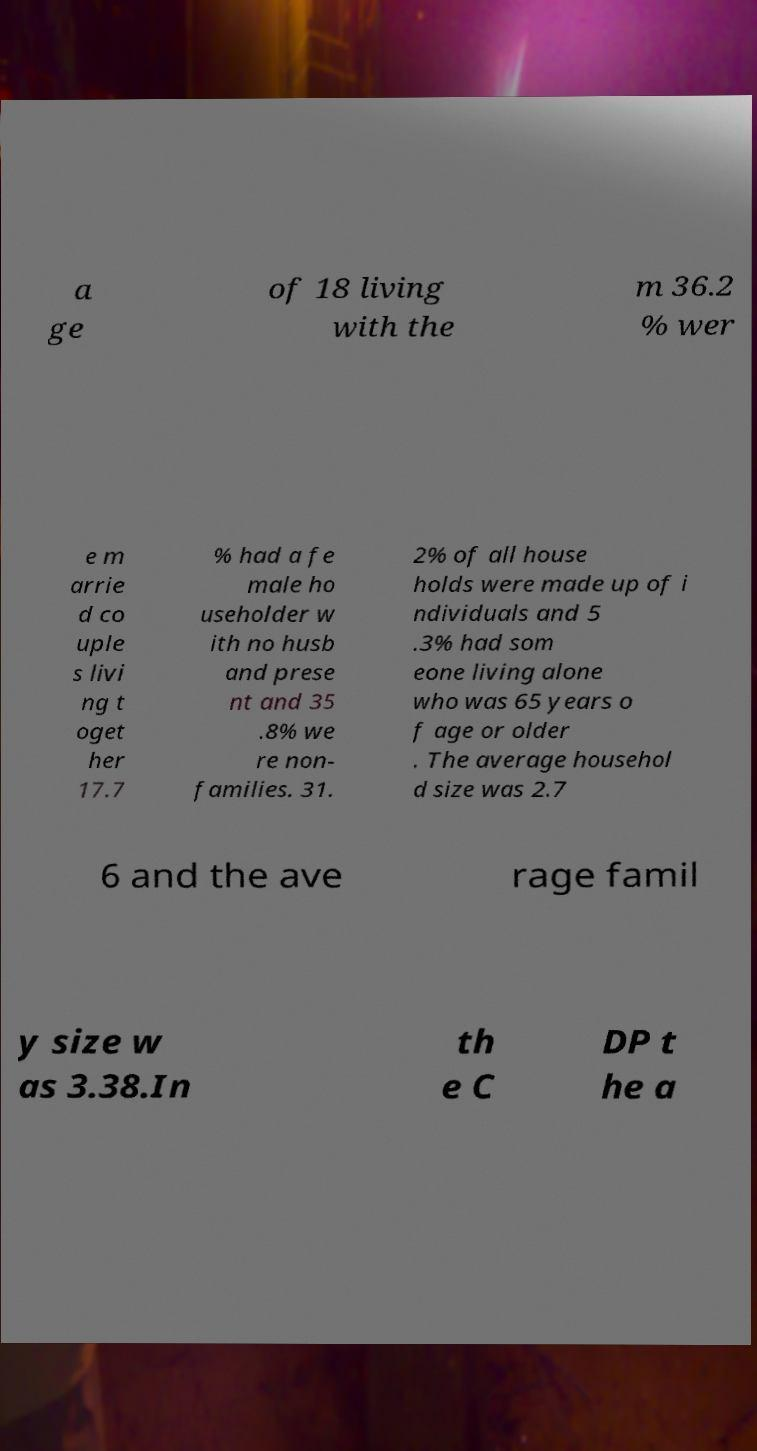Could you extract and type out the text from this image? a ge of 18 living with the m 36.2 % wer e m arrie d co uple s livi ng t oget her 17.7 % had a fe male ho useholder w ith no husb and prese nt and 35 .8% we re non- families. 31. 2% of all house holds were made up of i ndividuals and 5 .3% had som eone living alone who was 65 years o f age or older . The average househol d size was 2.7 6 and the ave rage famil y size w as 3.38.In th e C DP t he a 